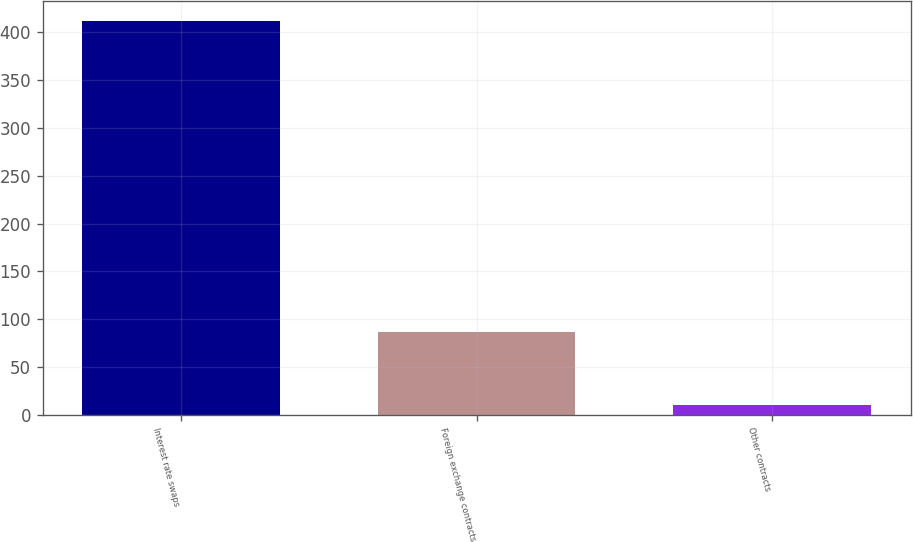Convert chart. <chart><loc_0><loc_0><loc_500><loc_500><bar_chart><fcel>Interest rate swaps<fcel>Foreign exchange contracts<fcel>Other contracts<nl><fcel>412<fcel>87<fcel>10<nl></chart> 